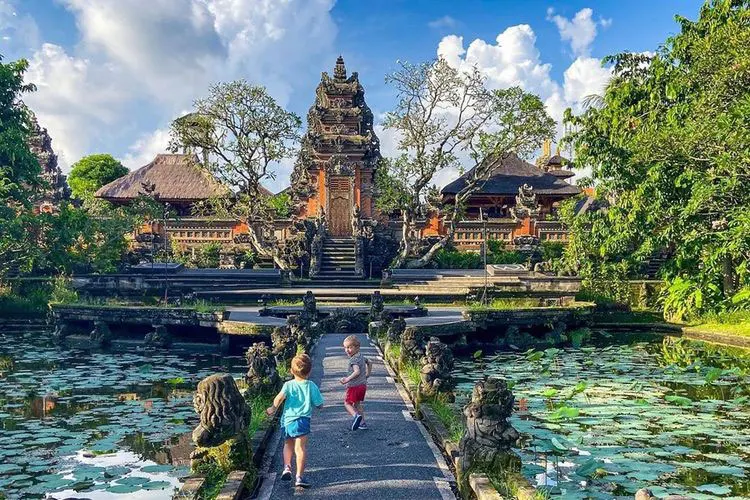What are the key elements in this picture? The image features the Ubud Water Palace in Bali, Indonesia, known for its stunning historical architecture and lush gardens. Key elements include the elaborately carved red brick structures reflective of Balinese royal aesthetics and the expansive pond adorned with lily pads, creating a serene atmosphere. The architecture incorporates Hindu influences, evident in the temple-like pagoda structures. Additionally, the presence of children playing on the path adds a dynamic contrast to the tranquil setting, portraying the palace as a place where culture and everyday life intersect. This scene captures both the grandeur of traditional Balinese architecture and the vibrant, living culture of the area. 